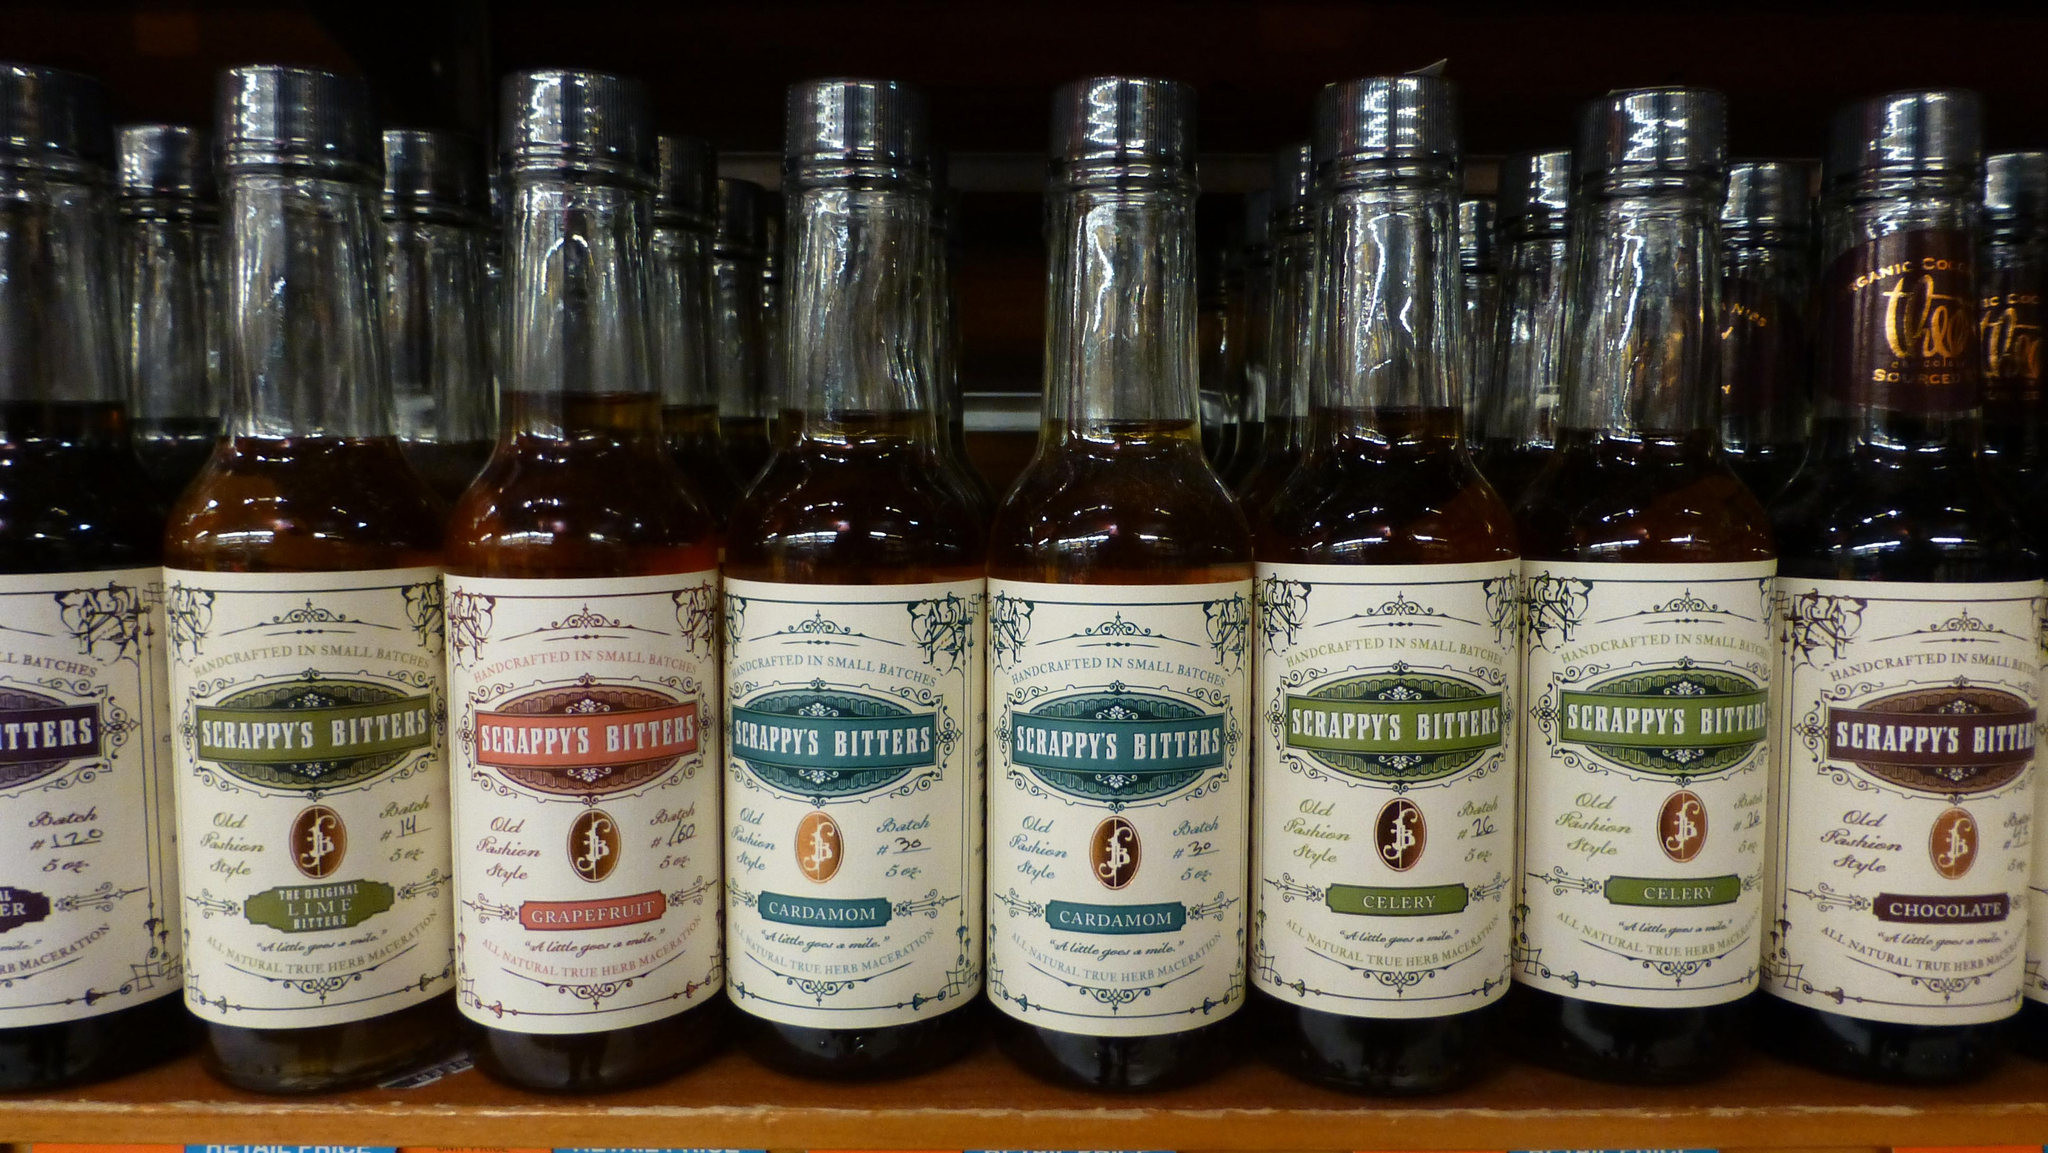What objects are present in the image? There are bottles in the image. Can you describe the bottles in the image? Unfortunately, the facts provided do not give any details about the bottles, so we cannot describe them further. How many bottles are visible in the image? The facts provided do not specify the number of bottles, so we cannot determine the exact number. What type of stew is being prepared by the father in the image? There is no mention of a stew or a father in the image, so this question cannot be answered based on the provided facts. 